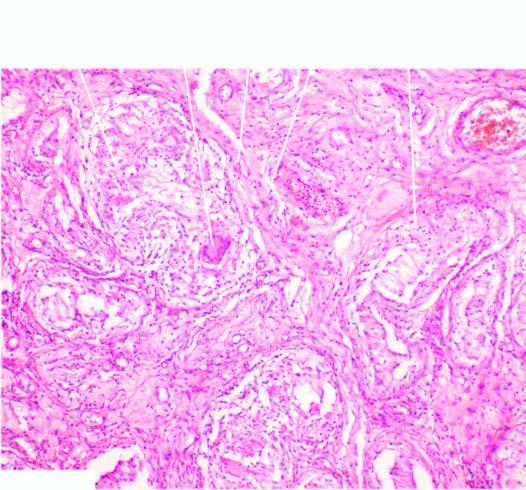what does the interstitium contain?
Answer the question using a single word or phrase. Several epithelioid cell granulomas with central areas of caseation necrosis 